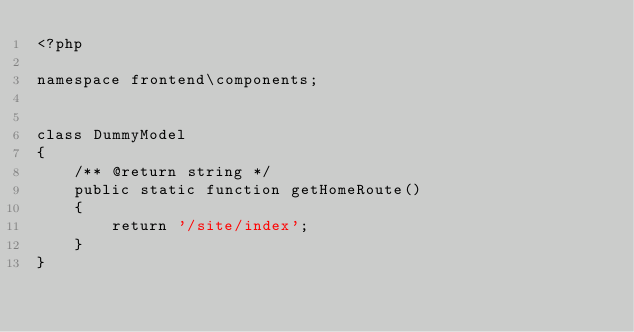Convert code to text. <code><loc_0><loc_0><loc_500><loc_500><_PHP_><?php

namespace frontend\components;


class DummyModel
{
    /** @return string */
    public static function getHomeRoute()
    {
        return '/site/index';
    }
}
</code> 